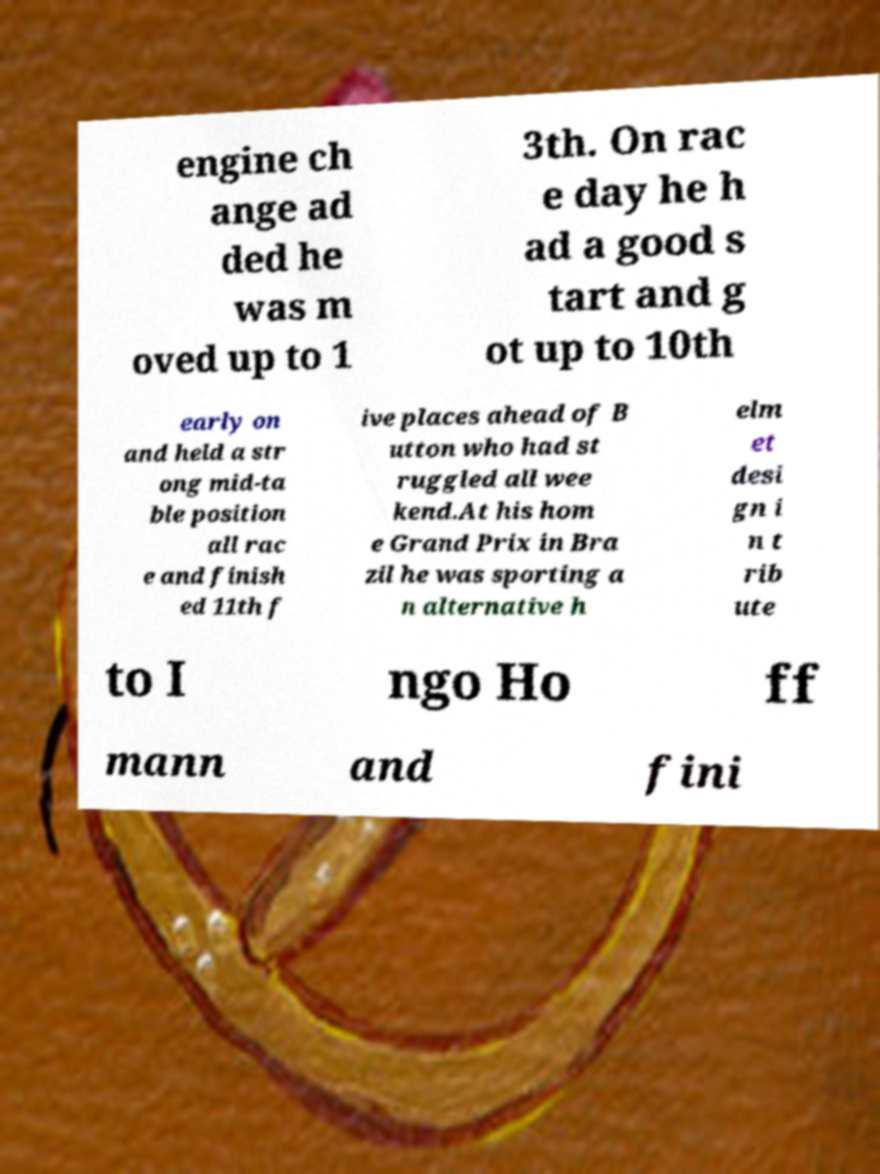Can you accurately transcribe the text from the provided image for me? engine ch ange ad ded he was m oved up to 1 3th. On rac e day he h ad a good s tart and g ot up to 10th early on and held a str ong mid-ta ble position all rac e and finish ed 11th f ive places ahead of B utton who had st ruggled all wee kend.At his hom e Grand Prix in Bra zil he was sporting a n alternative h elm et desi gn i n t rib ute to I ngo Ho ff mann and fini 